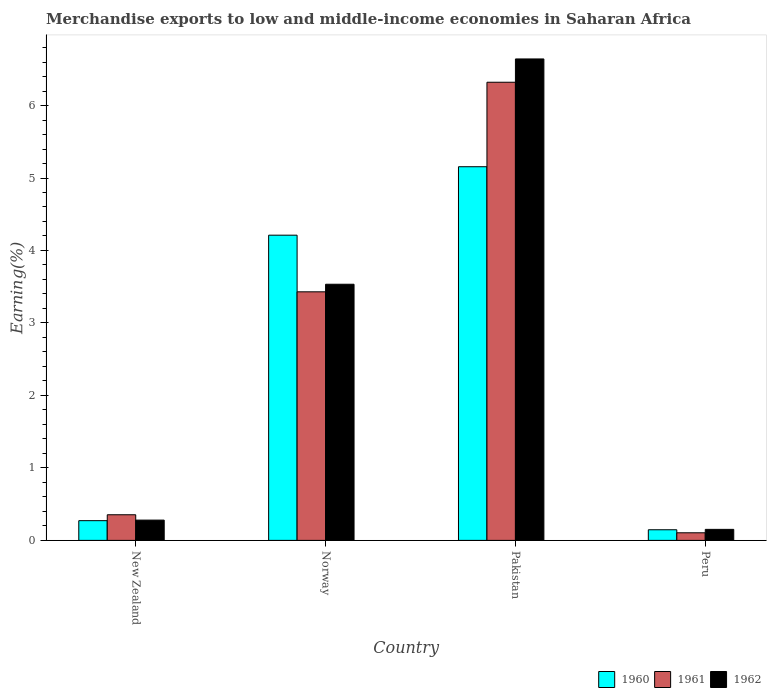Are the number of bars per tick equal to the number of legend labels?
Your answer should be very brief. Yes. How many bars are there on the 1st tick from the left?
Provide a short and direct response. 3. How many bars are there on the 2nd tick from the right?
Make the answer very short. 3. What is the label of the 1st group of bars from the left?
Keep it short and to the point. New Zealand. In how many cases, is the number of bars for a given country not equal to the number of legend labels?
Your answer should be very brief. 0. What is the percentage of amount earned from merchandise exports in 1962 in Pakistan?
Ensure brevity in your answer.  6.64. Across all countries, what is the maximum percentage of amount earned from merchandise exports in 1960?
Your answer should be compact. 5.16. Across all countries, what is the minimum percentage of amount earned from merchandise exports in 1960?
Provide a short and direct response. 0.15. In which country was the percentage of amount earned from merchandise exports in 1961 minimum?
Your answer should be compact. Peru. What is the total percentage of amount earned from merchandise exports in 1962 in the graph?
Offer a terse response. 10.61. What is the difference between the percentage of amount earned from merchandise exports in 1961 in Norway and that in Peru?
Your answer should be compact. 3.32. What is the difference between the percentage of amount earned from merchandise exports in 1961 in Norway and the percentage of amount earned from merchandise exports in 1960 in New Zealand?
Offer a very short reply. 3.16. What is the average percentage of amount earned from merchandise exports in 1960 per country?
Your answer should be very brief. 2.45. What is the difference between the percentage of amount earned from merchandise exports of/in 1962 and percentage of amount earned from merchandise exports of/in 1960 in Pakistan?
Your response must be concise. 1.49. What is the ratio of the percentage of amount earned from merchandise exports in 1962 in New Zealand to that in Norway?
Offer a terse response. 0.08. Is the difference between the percentage of amount earned from merchandise exports in 1962 in New Zealand and Peru greater than the difference between the percentage of amount earned from merchandise exports in 1960 in New Zealand and Peru?
Provide a short and direct response. Yes. What is the difference between the highest and the second highest percentage of amount earned from merchandise exports in 1962?
Provide a short and direct response. -3.25. What is the difference between the highest and the lowest percentage of amount earned from merchandise exports in 1962?
Keep it short and to the point. 6.49. In how many countries, is the percentage of amount earned from merchandise exports in 1961 greater than the average percentage of amount earned from merchandise exports in 1961 taken over all countries?
Offer a terse response. 2. Is the sum of the percentage of amount earned from merchandise exports in 1961 in New Zealand and Norway greater than the maximum percentage of amount earned from merchandise exports in 1962 across all countries?
Keep it short and to the point. No. What does the 1st bar from the right in Pakistan represents?
Ensure brevity in your answer.  1962. Is it the case that in every country, the sum of the percentage of amount earned from merchandise exports in 1961 and percentage of amount earned from merchandise exports in 1962 is greater than the percentage of amount earned from merchandise exports in 1960?
Your response must be concise. Yes. How many bars are there?
Offer a terse response. 12. Are all the bars in the graph horizontal?
Ensure brevity in your answer.  No. How many countries are there in the graph?
Your answer should be compact. 4. Does the graph contain grids?
Your response must be concise. No. What is the title of the graph?
Provide a succinct answer. Merchandise exports to low and middle-income economies in Saharan Africa. What is the label or title of the X-axis?
Your answer should be compact. Country. What is the label or title of the Y-axis?
Your answer should be compact. Earning(%). What is the Earning(%) of 1960 in New Zealand?
Give a very brief answer. 0.27. What is the Earning(%) in 1961 in New Zealand?
Your answer should be very brief. 0.35. What is the Earning(%) in 1962 in New Zealand?
Your answer should be compact. 0.28. What is the Earning(%) in 1960 in Norway?
Your answer should be very brief. 4.21. What is the Earning(%) in 1961 in Norway?
Offer a very short reply. 3.43. What is the Earning(%) in 1962 in Norway?
Your answer should be very brief. 3.53. What is the Earning(%) in 1960 in Pakistan?
Your answer should be very brief. 5.16. What is the Earning(%) of 1961 in Pakistan?
Provide a short and direct response. 6.32. What is the Earning(%) of 1962 in Pakistan?
Your answer should be very brief. 6.64. What is the Earning(%) of 1960 in Peru?
Offer a very short reply. 0.15. What is the Earning(%) of 1961 in Peru?
Make the answer very short. 0.1. What is the Earning(%) in 1962 in Peru?
Provide a succinct answer. 0.15. Across all countries, what is the maximum Earning(%) in 1960?
Your answer should be compact. 5.16. Across all countries, what is the maximum Earning(%) in 1961?
Ensure brevity in your answer.  6.32. Across all countries, what is the maximum Earning(%) of 1962?
Your answer should be compact. 6.64. Across all countries, what is the minimum Earning(%) in 1960?
Make the answer very short. 0.15. Across all countries, what is the minimum Earning(%) of 1961?
Your answer should be compact. 0.1. Across all countries, what is the minimum Earning(%) of 1962?
Keep it short and to the point. 0.15. What is the total Earning(%) of 1960 in the graph?
Ensure brevity in your answer.  9.79. What is the total Earning(%) of 1961 in the graph?
Your answer should be very brief. 10.21. What is the total Earning(%) in 1962 in the graph?
Offer a terse response. 10.61. What is the difference between the Earning(%) in 1960 in New Zealand and that in Norway?
Offer a very short reply. -3.94. What is the difference between the Earning(%) in 1961 in New Zealand and that in Norway?
Offer a terse response. -3.08. What is the difference between the Earning(%) of 1962 in New Zealand and that in Norway?
Ensure brevity in your answer.  -3.25. What is the difference between the Earning(%) in 1960 in New Zealand and that in Pakistan?
Offer a terse response. -4.88. What is the difference between the Earning(%) in 1961 in New Zealand and that in Pakistan?
Make the answer very short. -5.97. What is the difference between the Earning(%) in 1962 in New Zealand and that in Pakistan?
Give a very brief answer. -6.36. What is the difference between the Earning(%) of 1960 in New Zealand and that in Peru?
Provide a short and direct response. 0.13. What is the difference between the Earning(%) of 1961 in New Zealand and that in Peru?
Give a very brief answer. 0.25. What is the difference between the Earning(%) in 1962 in New Zealand and that in Peru?
Your response must be concise. 0.13. What is the difference between the Earning(%) of 1960 in Norway and that in Pakistan?
Keep it short and to the point. -0.94. What is the difference between the Earning(%) of 1961 in Norway and that in Pakistan?
Keep it short and to the point. -2.89. What is the difference between the Earning(%) in 1962 in Norway and that in Pakistan?
Your response must be concise. -3.11. What is the difference between the Earning(%) of 1960 in Norway and that in Peru?
Your answer should be compact. 4.06. What is the difference between the Earning(%) of 1961 in Norway and that in Peru?
Your answer should be compact. 3.32. What is the difference between the Earning(%) of 1962 in Norway and that in Peru?
Provide a succinct answer. 3.38. What is the difference between the Earning(%) of 1960 in Pakistan and that in Peru?
Offer a terse response. 5.01. What is the difference between the Earning(%) in 1961 in Pakistan and that in Peru?
Your response must be concise. 6.22. What is the difference between the Earning(%) of 1962 in Pakistan and that in Peru?
Your answer should be compact. 6.49. What is the difference between the Earning(%) of 1960 in New Zealand and the Earning(%) of 1961 in Norway?
Offer a very short reply. -3.16. What is the difference between the Earning(%) of 1960 in New Zealand and the Earning(%) of 1962 in Norway?
Your response must be concise. -3.26. What is the difference between the Earning(%) in 1961 in New Zealand and the Earning(%) in 1962 in Norway?
Offer a very short reply. -3.18. What is the difference between the Earning(%) of 1960 in New Zealand and the Earning(%) of 1961 in Pakistan?
Provide a succinct answer. -6.05. What is the difference between the Earning(%) in 1960 in New Zealand and the Earning(%) in 1962 in Pakistan?
Ensure brevity in your answer.  -6.37. What is the difference between the Earning(%) of 1961 in New Zealand and the Earning(%) of 1962 in Pakistan?
Provide a short and direct response. -6.29. What is the difference between the Earning(%) of 1960 in New Zealand and the Earning(%) of 1961 in Peru?
Give a very brief answer. 0.17. What is the difference between the Earning(%) of 1960 in New Zealand and the Earning(%) of 1962 in Peru?
Offer a very short reply. 0.12. What is the difference between the Earning(%) of 1961 in New Zealand and the Earning(%) of 1962 in Peru?
Provide a short and direct response. 0.2. What is the difference between the Earning(%) of 1960 in Norway and the Earning(%) of 1961 in Pakistan?
Provide a succinct answer. -2.11. What is the difference between the Earning(%) in 1960 in Norway and the Earning(%) in 1962 in Pakistan?
Provide a short and direct response. -2.43. What is the difference between the Earning(%) in 1961 in Norway and the Earning(%) in 1962 in Pakistan?
Give a very brief answer. -3.21. What is the difference between the Earning(%) in 1960 in Norway and the Earning(%) in 1961 in Peru?
Offer a very short reply. 4.11. What is the difference between the Earning(%) in 1960 in Norway and the Earning(%) in 1962 in Peru?
Provide a succinct answer. 4.06. What is the difference between the Earning(%) in 1961 in Norway and the Earning(%) in 1962 in Peru?
Your answer should be compact. 3.28. What is the difference between the Earning(%) of 1960 in Pakistan and the Earning(%) of 1961 in Peru?
Provide a succinct answer. 5.05. What is the difference between the Earning(%) in 1960 in Pakistan and the Earning(%) in 1962 in Peru?
Make the answer very short. 5. What is the difference between the Earning(%) of 1961 in Pakistan and the Earning(%) of 1962 in Peru?
Ensure brevity in your answer.  6.17. What is the average Earning(%) in 1960 per country?
Your answer should be very brief. 2.45. What is the average Earning(%) in 1961 per country?
Provide a succinct answer. 2.55. What is the average Earning(%) in 1962 per country?
Your answer should be compact. 2.65. What is the difference between the Earning(%) of 1960 and Earning(%) of 1961 in New Zealand?
Your answer should be very brief. -0.08. What is the difference between the Earning(%) of 1960 and Earning(%) of 1962 in New Zealand?
Your response must be concise. -0.01. What is the difference between the Earning(%) in 1961 and Earning(%) in 1962 in New Zealand?
Keep it short and to the point. 0.07. What is the difference between the Earning(%) of 1960 and Earning(%) of 1961 in Norway?
Your answer should be compact. 0.78. What is the difference between the Earning(%) in 1960 and Earning(%) in 1962 in Norway?
Make the answer very short. 0.68. What is the difference between the Earning(%) of 1961 and Earning(%) of 1962 in Norway?
Provide a succinct answer. -0.1. What is the difference between the Earning(%) of 1960 and Earning(%) of 1961 in Pakistan?
Provide a succinct answer. -1.17. What is the difference between the Earning(%) of 1960 and Earning(%) of 1962 in Pakistan?
Your answer should be compact. -1.49. What is the difference between the Earning(%) of 1961 and Earning(%) of 1962 in Pakistan?
Your answer should be very brief. -0.32. What is the difference between the Earning(%) in 1960 and Earning(%) in 1961 in Peru?
Provide a short and direct response. 0.04. What is the difference between the Earning(%) of 1960 and Earning(%) of 1962 in Peru?
Make the answer very short. -0.01. What is the difference between the Earning(%) of 1961 and Earning(%) of 1962 in Peru?
Ensure brevity in your answer.  -0.05. What is the ratio of the Earning(%) in 1960 in New Zealand to that in Norway?
Provide a succinct answer. 0.06. What is the ratio of the Earning(%) in 1961 in New Zealand to that in Norway?
Provide a succinct answer. 0.1. What is the ratio of the Earning(%) of 1962 in New Zealand to that in Norway?
Give a very brief answer. 0.08. What is the ratio of the Earning(%) of 1960 in New Zealand to that in Pakistan?
Keep it short and to the point. 0.05. What is the ratio of the Earning(%) in 1961 in New Zealand to that in Pakistan?
Your answer should be compact. 0.06. What is the ratio of the Earning(%) in 1962 in New Zealand to that in Pakistan?
Make the answer very short. 0.04. What is the ratio of the Earning(%) in 1960 in New Zealand to that in Peru?
Ensure brevity in your answer.  1.85. What is the ratio of the Earning(%) of 1961 in New Zealand to that in Peru?
Offer a very short reply. 3.37. What is the ratio of the Earning(%) in 1962 in New Zealand to that in Peru?
Provide a succinct answer. 1.84. What is the ratio of the Earning(%) of 1960 in Norway to that in Pakistan?
Keep it short and to the point. 0.82. What is the ratio of the Earning(%) in 1961 in Norway to that in Pakistan?
Ensure brevity in your answer.  0.54. What is the ratio of the Earning(%) in 1962 in Norway to that in Pakistan?
Keep it short and to the point. 0.53. What is the ratio of the Earning(%) of 1960 in Norway to that in Peru?
Ensure brevity in your answer.  28.69. What is the ratio of the Earning(%) of 1961 in Norway to that in Peru?
Provide a short and direct response. 32.67. What is the ratio of the Earning(%) in 1962 in Norway to that in Peru?
Ensure brevity in your answer.  23.23. What is the ratio of the Earning(%) in 1960 in Pakistan to that in Peru?
Offer a very short reply. 35.13. What is the ratio of the Earning(%) in 1961 in Pakistan to that in Peru?
Your response must be concise. 60.22. What is the ratio of the Earning(%) of 1962 in Pakistan to that in Peru?
Your response must be concise. 43.66. What is the difference between the highest and the second highest Earning(%) of 1961?
Make the answer very short. 2.89. What is the difference between the highest and the second highest Earning(%) of 1962?
Your answer should be very brief. 3.11. What is the difference between the highest and the lowest Earning(%) in 1960?
Ensure brevity in your answer.  5.01. What is the difference between the highest and the lowest Earning(%) of 1961?
Your answer should be compact. 6.22. What is the difference between the highest and the lowest Earning(%) of 1962?
Your answer should be very brief. 6.49. 